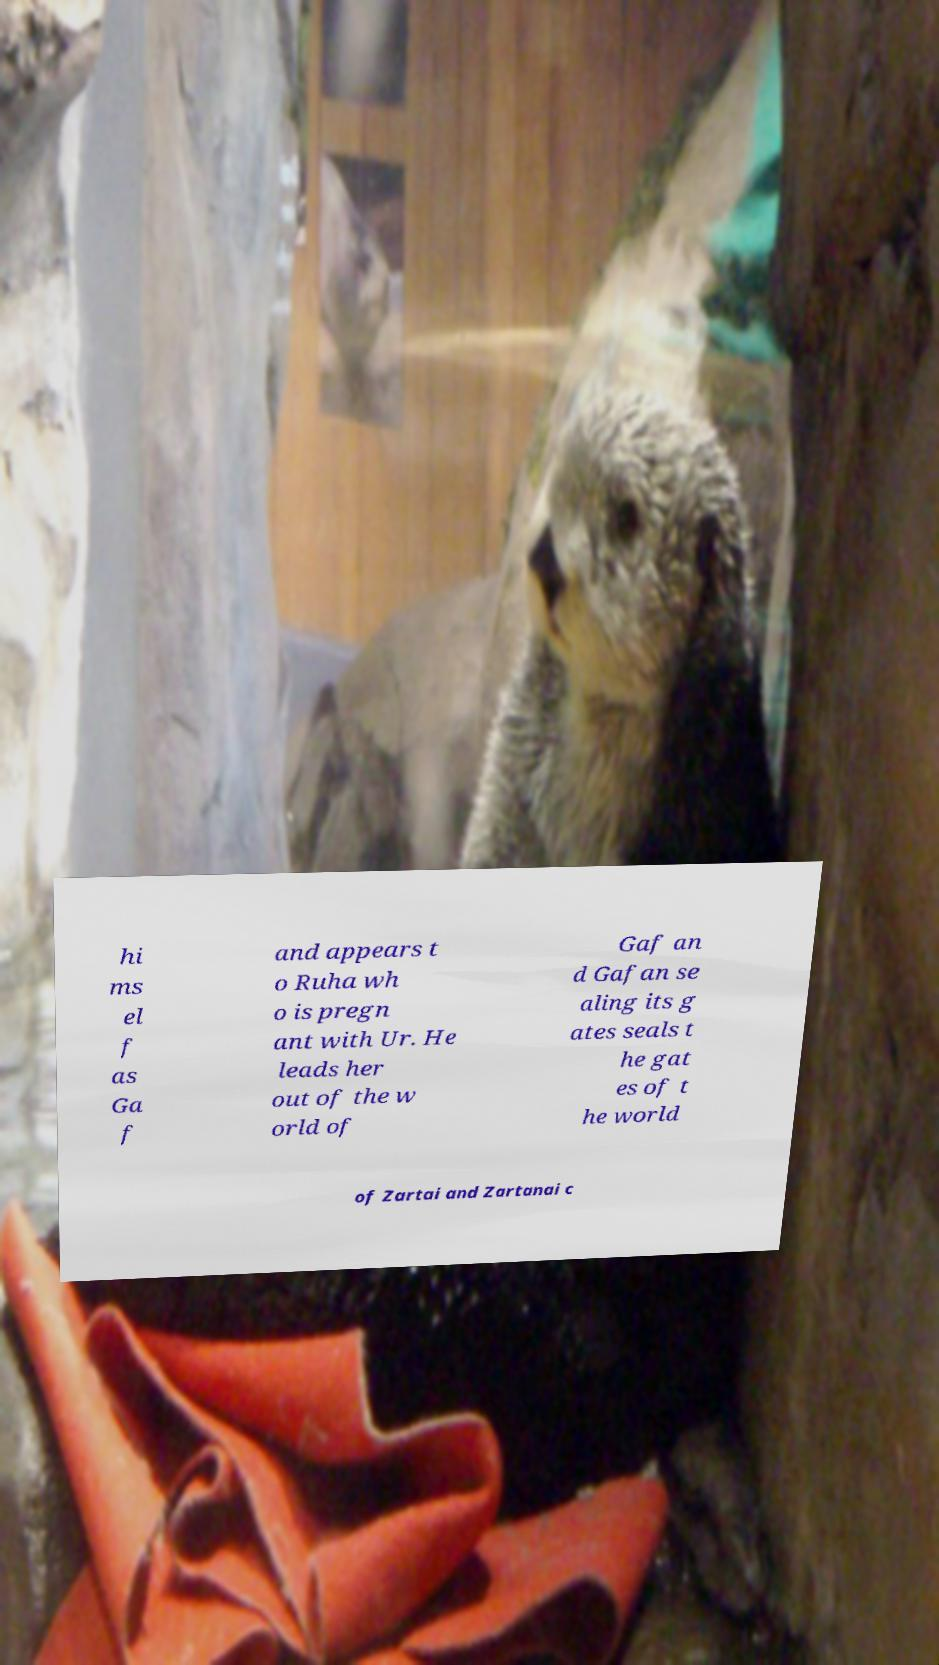Please identify and transcribe the text found in this image. hi ms el f as Ga f and appears t o Ruha wh o is pregn ant with Ur. He leads her out of the w orld of Gaf an d Gafan se aling its g ates seals t he gat es of t he world of Zartai and Zartanai c 